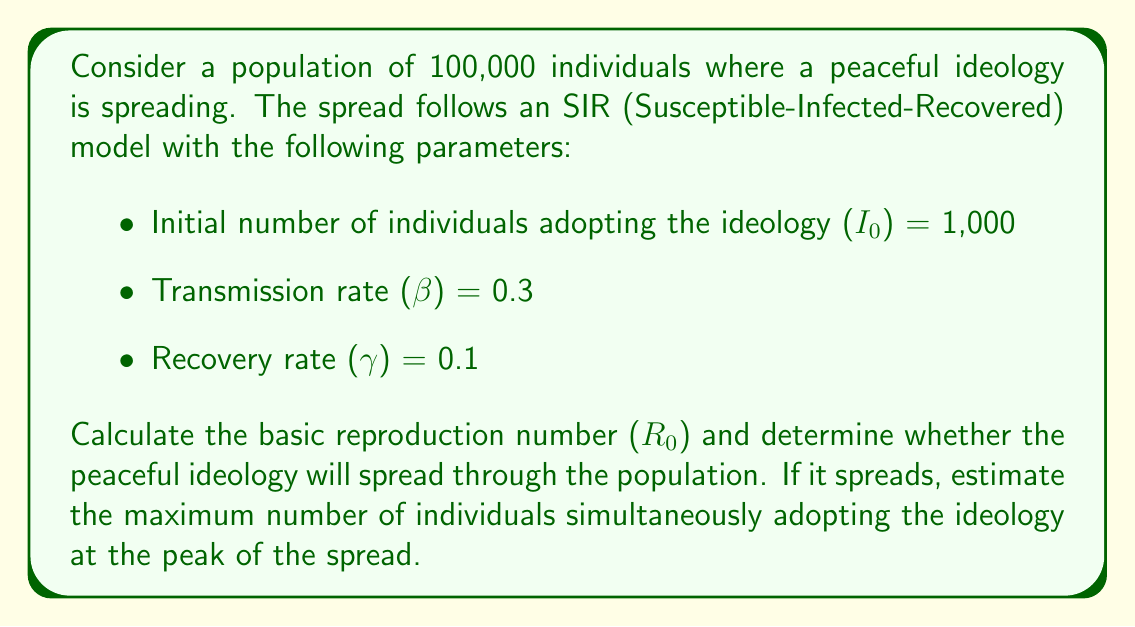Teach me how to tackle this problem. 1. Calculate the basic reproduction number (R₀):
   R₀ is given by the formula: $R_0 = \frac{\beta}{\gamma}$
   
   Substituting the values:
   $$R_0 = \frac{0.3}{0.1} = 3$$

2. Determine if the ideology will spread:
   Since R₀ > 1, the peaceful ideology will spread through the population.

3. Estimate the maximum number of individuals adopting the ideology at the peak:
   For an SIR model, the maximum occurs when $S = \frac{N}{R_0}$, where N is the total population.

   $$S = \frac{100,000}{3} \approx 33,333$$

   The number of individuals who have adopted the ideology at this point is:
   $$I_{max} = N - S - R$$
   
   We don't know R at this point, but we can approximate it as very small compared to N and S.
   
   $$I_{max} \approx N - S = 100,000 - 33,333 \approx 66,667$$

4. A more precise calculation uses the formula:
   $$I_{max} = N \left(1 - \frac{1 + \ln R_0}{R_0}\right)$$

   Substituting the values:
   $$I_{max} = 100,000 \left(1 - \frac{1 + \ln 3}{3}\right) \approx 63,212$$

This more precise calculation gives us the final estimate for the maximum number of individuals simultaneously adopting the ideology at the peak of the spread.
Answer: R₀ = 3; Ideology will spread; I_max ≈ 63,212 individuals 